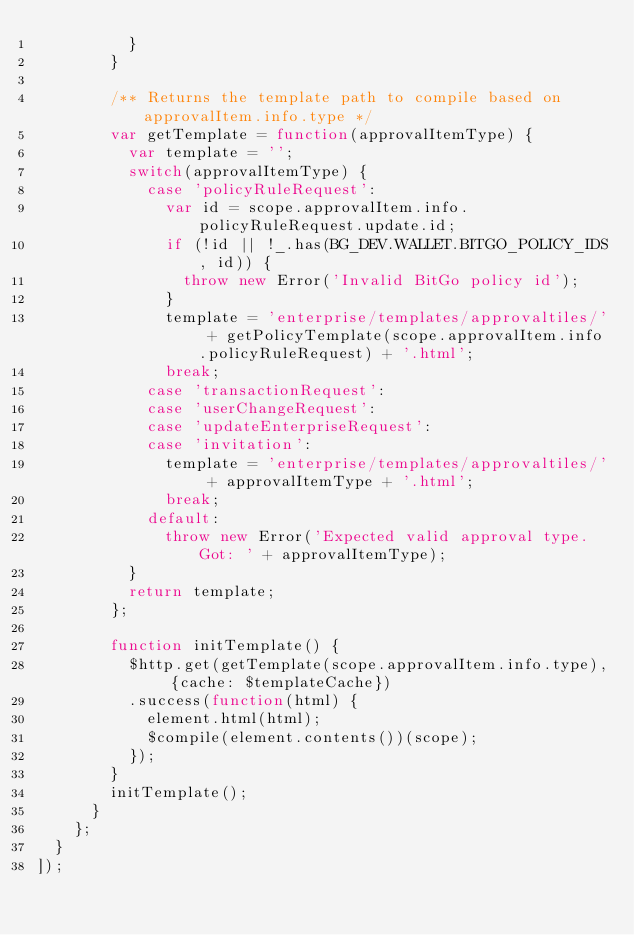<code> <loc_0><loc_0><loc_500><loc_500><_JavaScript_>          }
        }

        /** Returns the template path to compile based on approvalItem.info.type */
        var getTemplate = function(approvalItemType) {
          var template = '';
          switch(approvalItemType) {
            case 'policyRuleRequest':
              var id = scope.approvalItem.info.policyRuleRequest.update.id;
              if (!id || !_.has(BG_DEV.WALLET.BITGO_POLICY_IDS, id)) {
                throw new Error('Invalid BitGo policy id');
              }
              template = 'enterprise/templates/approvaltiles/' + getPolicyTemplate(scope.approvalItem.info.policyRuleRequest) + '.html';
              break;
            case 'transactionRequest':
            case 'userChangeRequest':
            case 'updateEnterpriseRequest':
            case 'invitation':
              template = 'enterprise/templates/approvaltiles/' + approvalItemType + '.html';
              break;
            default:
              throw new Error('Expected valid approval type. Got: ' + approvalItemType);
          }
          return template;
        };

        function initTemplate() {
          $http.get(getTemplate(scope.approvalItem.info.type), {cache: $templateCache})
          .success(function(html) {
            element.html(html);
            $compile(element.contents())(scope);
          });
        }
        initTemplate();
      }
    };
  }
]);
</code> 